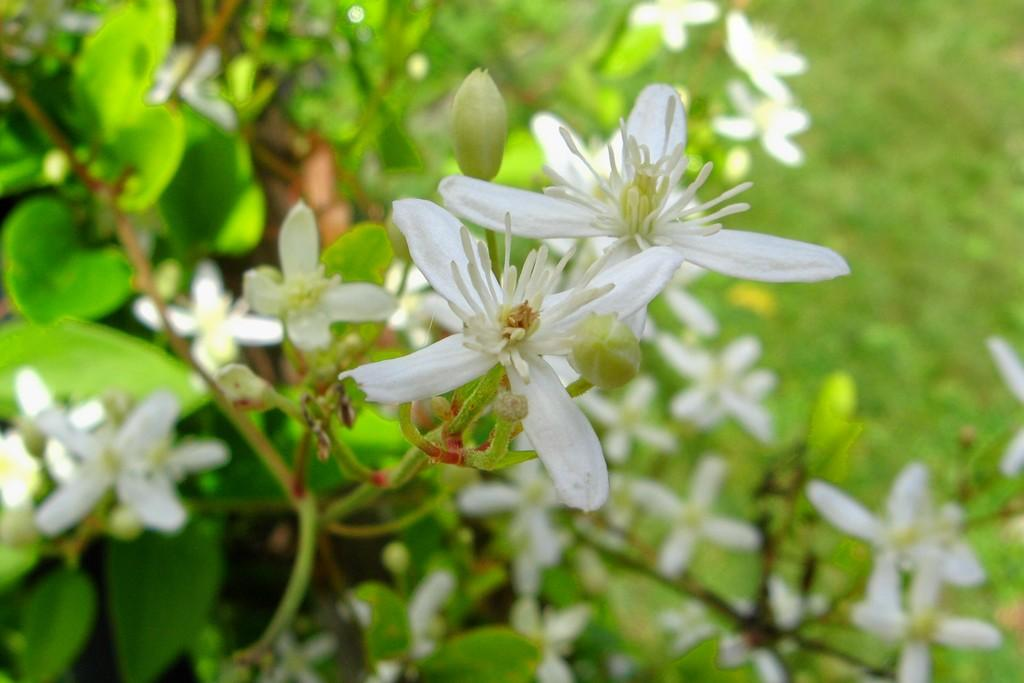What type of plants are visible in the image? There are plants with flowers in the image. Can you describe the background of the image? The background of the image is blurred. Who is the creator of the cloth in the image? There is no cloth present in the image, so it is not possible to determine who the creator might be. 